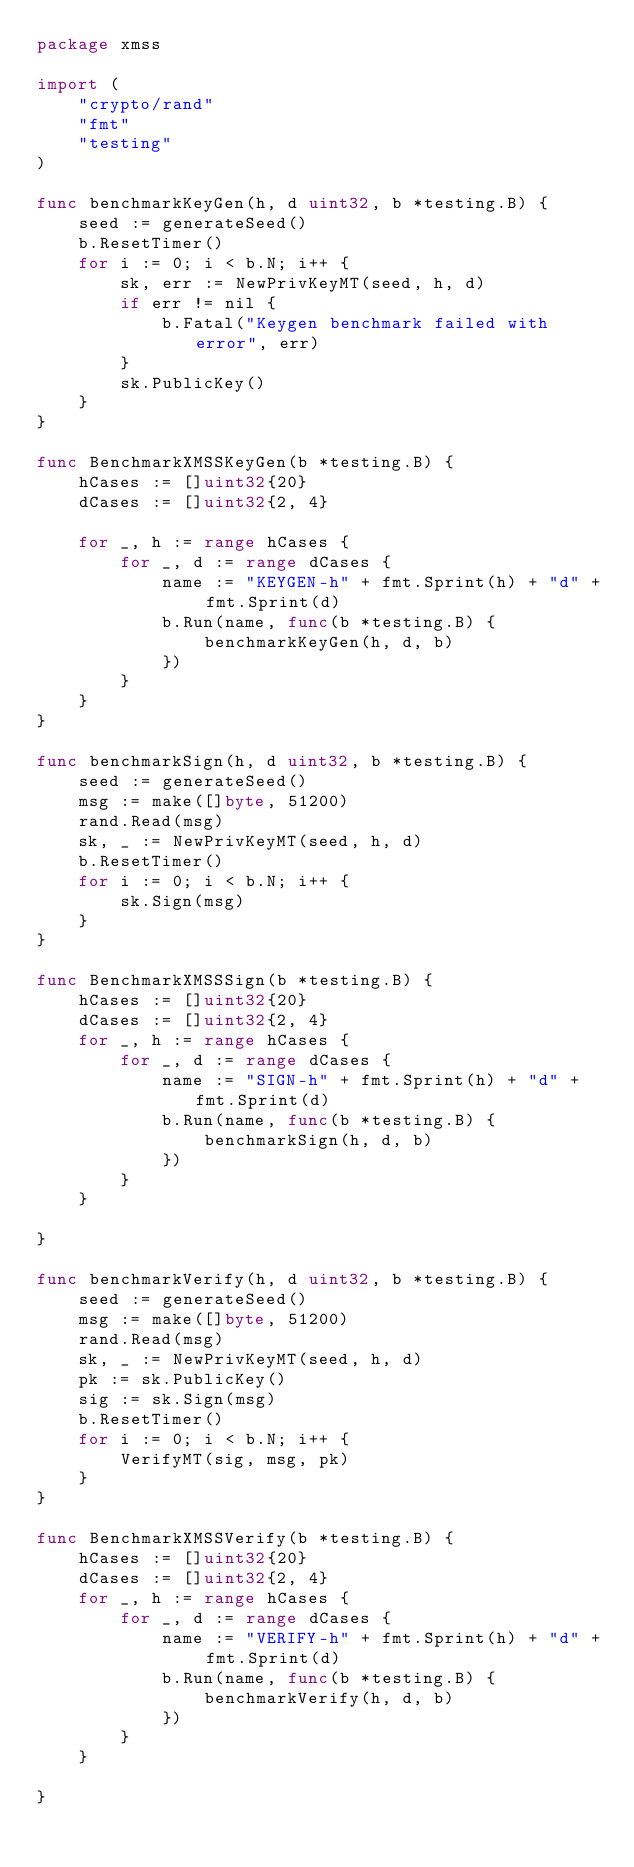<code> <loc_0><loc_0><loc_500><loc_500><_Go_>package xmss

import (
	"crypto/rand"
	"fmt"
	"testing"
)

func benchmarkKeyGen(h, d uint32, b *testing.B) {
	seed := generateSeed()
	b.ResetTimer()
	for i := 0; i < b.N; i++ {
		sk, err := NewPrivKeyMT(seed, h, d)
		if err != nil {
			b.Fatal("Keygen benchmark failed with error", err)
		}
		sk.PublicKey()
	}
}

func BenchmarkXMSSKeyGen(b *testing.B) {
	hCases := []uint32{20}
	dCases := []uint32{2, 4}

	for _, h := range hCases {
		for _, d := range dCases {
			name := "KEYGEN-h" + fmt.Sprint(h) + "d" + fmt.Sprint(d)
			b.Run(name, func(b *testing.B) {
				benchmarkKeyGen(h, d, b)
			})
		}
	}
}

func benchmarkSign(h, d uint32, b *testing.B) {
	seed := generateSeed()
	msg := make([]byte, 51200)
	rand.Read(msg)
	sk, _ := NewPrivKeyMT(seed, h, d)
	b.ResetTimer()
	for i := 0; i < b.N; i++ {
		sk.Sign(msg)
	}
}

func BenchmarkXMSSSign(b *testing.B) {
	hCases := []uint32{20}
	dCases := []uint32{2, 4}
	for _, h := range hCases {
		for _, d := range dCases {
			name := "SIGN-h" + fmt.Sprint(h) + "d" + fmt.Sprint(d)
			b.Run(name, func(b *testing.B) {
				benchmarkSign(h, d, b)
			})
		}
	}

}

func benchmarkVerify(h, d uint32, b *testing.B) {
	seed := generateSeed()
	msg := make([]byte, 51200)
	rand.Read(msg)
	sk, _ := NewPrivKeyMT(seed, h, d)
	pk := sk.PublicKey()
	sig := sk.Sign(msg)
	b.ResetTimer()
	for i := 0; i < b.N; i++ {
		VerifyMT(sig, msg, pk)
	}
}

func BenchmarkXMSSVerify(b *testing.B) {
	hCases := []uint32{20}
	dCases := []uint32{2, 4}
	for _, h := range hCases {
		for _, d := range dCases {
			name := "VERIFY-h" + fmt.Sprint(h) + "d" + fmt.Sprint(d)
			b.Run(name, func(b *testing.B) {
				benchmarkVerify(h, d, b)
			})
		}
	}

}
</code> 